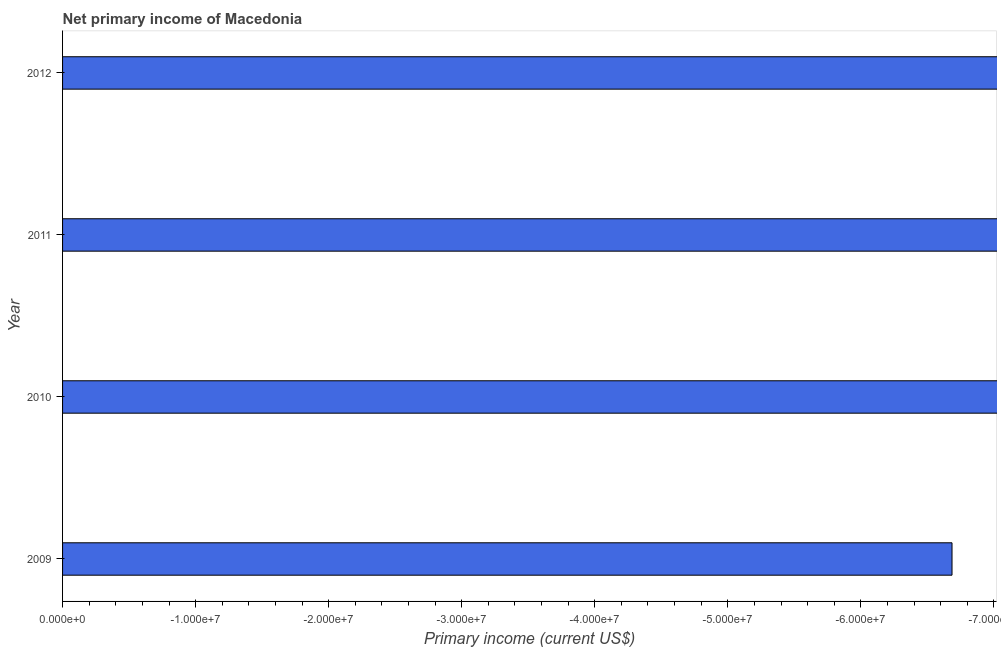Does the graph contain any zero values?
Keep it short and to the point. Yes. What is the title of the graph?
Keep it short and to the point. Net primary income of Macedonia. What is the label or title of the X-axis?
Provide a succinct answer. Primary income (current US$). What is the median amount of primary income?
Make the answer very short. 0. In how many years, is the amount of primary income greater than -26000000 US$?
Provide a short and direct response. 0. What is the Primary income (current US$) in 2011?
Keep it short and to the point. 0. 